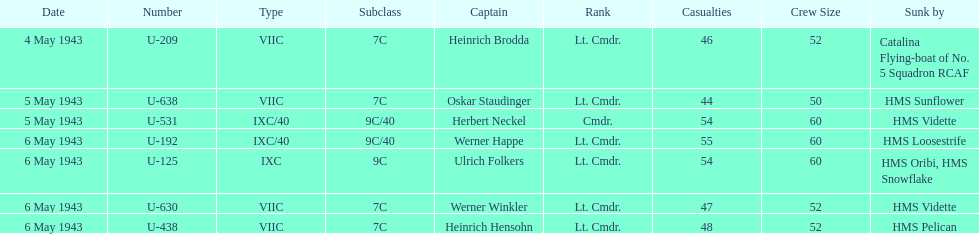Which ship sunk the most u-boats HMS Vidette. Could you parse the entire table as a dict? {'header': ['Date', 'Number', 'Type', 'Subclass', 'Captain', 'Rank', 'Casualties', 'Crew Size', 'Sunk by'], 'rows': [['4 May 1943', 'U-209', 'VIIC', '7C', 'Heinrich Brodda', 'Lt. Cmdr.', '46', '52', 'Catalina Flying-boat of No. 5 Squadron RCAF'], ['5 May 1943', 'U-638', 'VIIC', '7C', 'Oskar Staudinger', 'Lt. Cmdr.', '44', '50', 'HMS Sunflower'], ['5 May 1943', 'U-531', 'IXC/40', '9C/40', 'Herbert Neckel', 'Cmdr.', '54', '60', 'HMS Vidette'], ['6 May 1943', 'U-192', 'IXC/40', '9C/40', 'Werner Happe', 'Lt. Cmdr.', '55', '60', 'HMS Loosestrife'], ['6 May 1943', 'U-125', 'IXC', '9C', 'Ulrich Folkers', 'Lt. Cmdr.', '54', '60', 'HMS Oribi, HMS Snowflake'], ['6 May 1943', 'U-630', 'VIIC', '7C', 'Werner Winkler', 'Lt. Cmdr.', '47', '52', 'HMS Vidette'], ['6 May 1943', 'U-438', 'VIIC', '7C', 'Heinrich Hensohn', 'Lt. Cmdr.', '48', '52', 'HMS Pelican']]} 